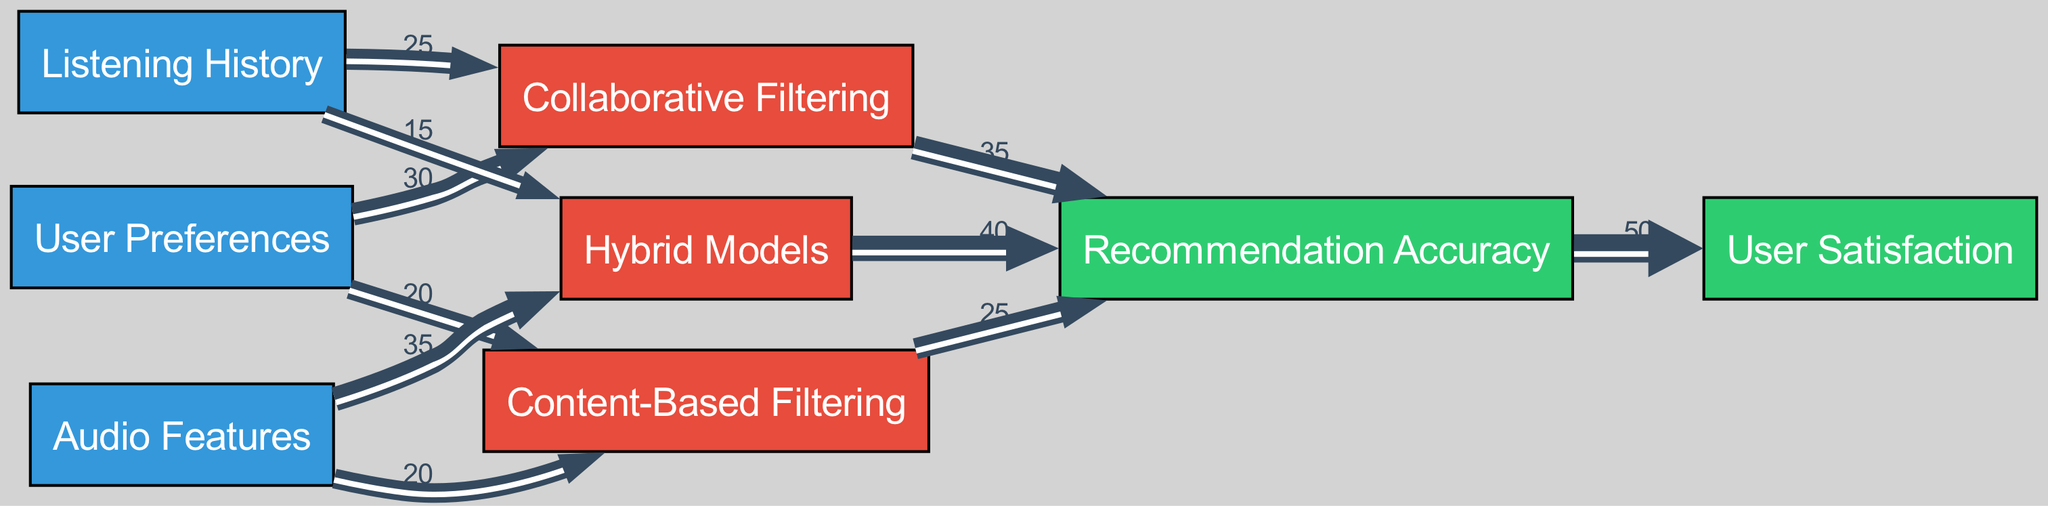What are the three sources of data in the diagram? The sources of data are identified in the diagram as 'User Preferences', 'Listening History', and 'Audio Features'.
Answer: User Preferences, Listening History, Audio Features Which filtering model has the highest contribution to Recommendation Accuracy? By evaluating the outgoing links from each algorithm node towards Recommendation Accuracy, 'Hybrid Models' has the highest value at 40 compared to others.
Answer: Hybrid Models What is the total contribution value from User Preferences to all algorithm models? The contribution from 'User Preferences' is calculated by adding its outgoing links: 30 (to Collaborative Filtering) + 20 (to Content-Based Filtering) = 50.
Answer: 50 How many nodes are designated as sinks in this diagram? The sink nodes in the diagram are 'Recommendation Accuracy' and 'User Satisfaction', amounting to a total of 2.
Answer: 2 Which algorithm receives the most input from Audio Features? The outgoing flow from 'Audio Features' indicates that 'Hybrid Models' receives the highest input with a value of 35.
Answer: Hybrid Models If the Recommendation Accuracy increases by 10, how will User Satisfaction be affected, based on the proportions shown? Currently, User Satisfaction is directly linked to Recommendation Accuracy with a flow of 50. If we assume the ratio remains constant, any increase in Recommendation Accuracy should proportionally increase User Satisfaction. For a 10 increase, it would remain related but the exact value will depend on the ratio of it, which currently is 50 out of unknown total User Satisfaction.
Answer: Indeterminate What is the combined flow from the algorithm models to Recommendation Accuracy? By summing the values flowing from the algorithm models to Recommendation Accuracy: 35 (Collaborative Filtering) + 25 (Content-Based Filtering) + 40 (Hybrid Models) = 100.
Answer: 100 Identify the algorithm that has the least amount of input from Listening History. The outgoing flow from 'Listening History' shows: 25 (Collaborative Filtering) and 15 (Hybrid Models). 'Hybrid Models' has the least input at 15.
Answer: Hybrid Models 